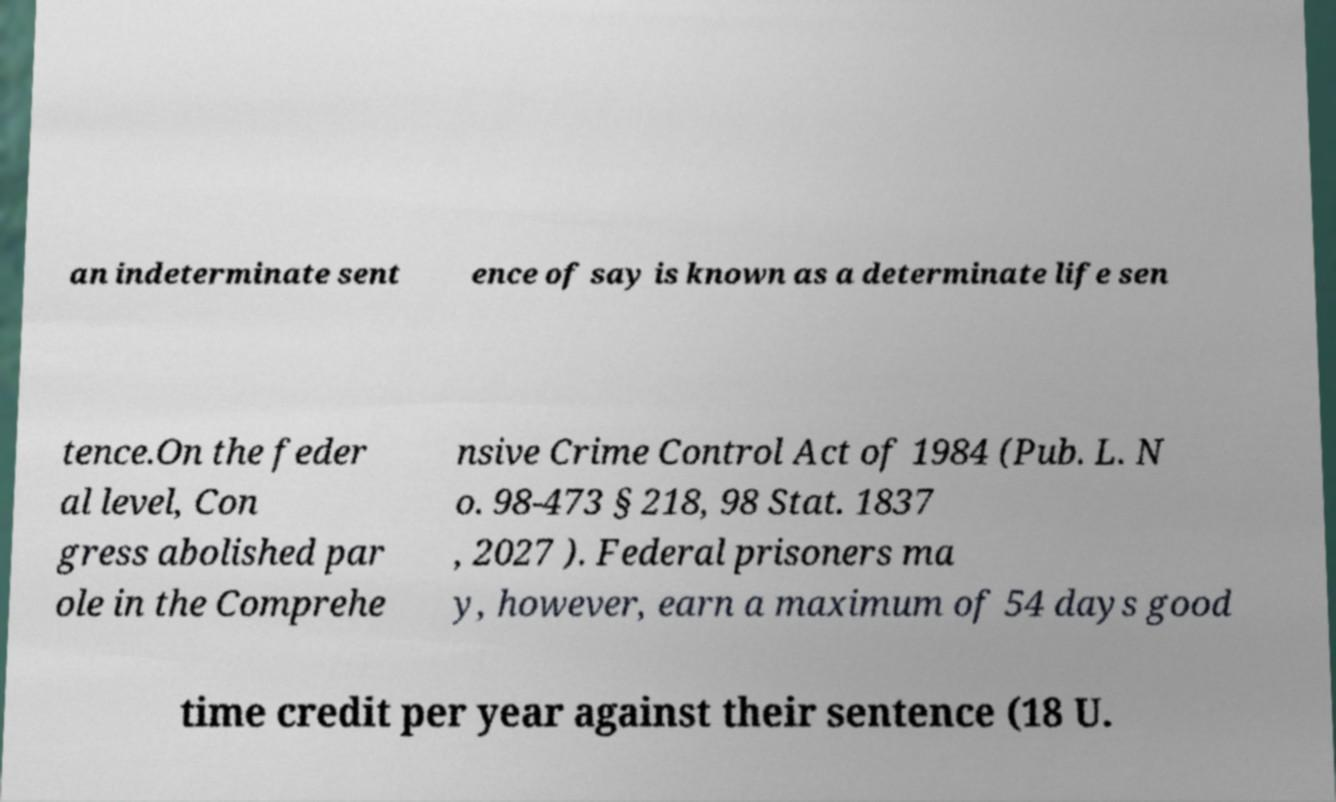What messages or text are displayed in this image? I need them in a readable, typed format. an indeterminate sent ence of say is known as a determinate life sen tence.On the feder al level, Con gress abolished par ole in the Comprehe nsive Crime Control Act of 1984 (Pub. L. N o. 98-473 § 218, 98 Stat. 1837 , 2027 ). Federal prisoners ma y, however, earn a maximum of 54 days good time credit per year against their sentence (18 U. 